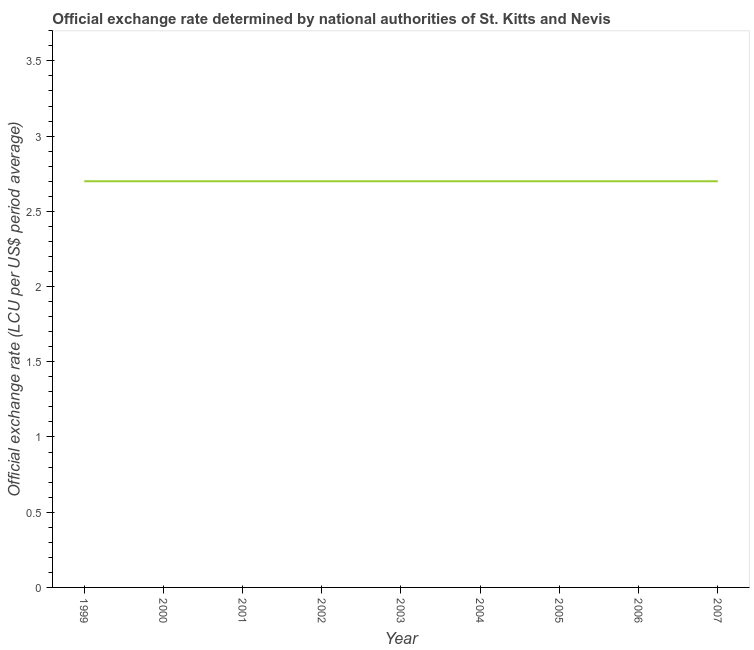What is the official exchange rate in 2004?
Your answer should be compact. 2.7. Across all years, what is the maximum official exchange rate?
Offer a terse response. 2.7. What is the sum of the official exchange rate?
Make the answer very short. 24.3. What is the median official exchange rate?
Give a very brief answer. 2.7. Do a majority of the years between 2002 and 2005 (inclusive) have official exchange rate greater than 0.7 ?
Make the answer very short. Yes. Is the official exchange rate in 1999 less than that in 2007?
Your answer should be compact. No. What is the difference between the highest and the second highest official exchange rate?
Offer a terse response. 0. Is the sum of the official exchange rate in 2001 and 2007 greater than the maximum official exchange rate across all years?
Offer a very short reply. Yes. What is the difference between the highest and the lowest official exchange rate?
Make the answer very short. 0. In how many years, is the official exchange rate greater than the average official exchange rate taken over all years?
Offer a very short reply. 0. How many lines are there?
Your answer should be very brief. 1. How many years are there in the graph?
Keep it short and to the point. 9. Does the graph contain grids?
Make the answer very short. No. What is the title of the graph?
Provide a short and direct response. Official exchange rate determined by national authorities of St. Kitts and Nevis. What is the label or title of the Y-axis?
Ensure brevity in your answer.  Official exchange rate (LCU per US$ period average). What is the Official exchange rate (LCU per US$ period average) in 1999?
Offer a very short reply. 2.7. What is the Official exchange rate (LCU per US$ period average) of 2001?
Make the answer very short. 2.7. What is the Official exchange rate (LCU per US$ period average) of 2005?
Keep it short and to the point. 2.7. What is the Official exchange rate (LCU per US$ period average) in 2006?
Offer a terse response. 2.7. What is the difference between the Official exchange rate (LCU per US$ period average) in 1999 and 2001?
Ensure brevity in your answer.  0. What is the difference between the Official exchange rate (LCU per US$ period average) in 1999 and 2003?
Your answer should be compact. 0. What is the difference between the Official exchange rate (LCU per US$ period average) in 1999 and 2004?
Your answer should be compact. 0. What is the difference between the Official exchange rate (LCU per US$ period average) in 1999 and 2006?
Give a very brief answer. 0. What is the difference between the Official exchange rate (LCU per US$ period average) in 2000 and 2003?
Give a very brief answer. 0. What is the difference between the Official exchange rate (LCU per US$ period average) in 2000 and 2004?
Give a very brief answer. 0. What is the difference between the Official exchange rate (LCU per US$ period average) in 2000 and 2006?
Offer a very short reply. 0. What is the difference between the Official exchange rate (LCU per US$ period average) in 2000 and 2007?
Provide a short and direct response. 0. What is the difference between the Official exchange rate (LCU per US$ period average) in 2001 and 2003?
Provide a succinct answer. 0. What is the difference between the Official exchange rate (LCU per US$ period average) in 2001 and 2004?
Provide a succinct answer. 0. What is the difference between the Official exchange rate (LCU per US$ period average) in 2001 and 2006?
Provide a short and direct response. 0. What is the difference between the Official exchange rate (LCU per US$ period average) in 2002 and 2005?
Your response must be concise. 0. What is the difference between the Official exchange rate (LCU per US$ period average) in 2003 and 2004?
Your answer should be compact. 0. What is the difference between the Official exchange rate (LCU per US$ period average) in 2003 and 2005?
Provide a succinct answer. 0. What is the difference between the Official exchange rate (LCU per US$ period average) in 2003 and 2006?
Keep it short and to the point. 0. What is the difference between the Official exchange rate (LCU per US$ period average) in 2003 and 2007?
Give a very brief answer. 0. What is the difference between the Official exchange rate (LCU per US$ period average) in 2004 and 2005?
Offer a terse response. 0. What is the difference between the Official exchange rate (LCU per US$ period average) in 2004 and 2007?
Make the answer very short. 0. What is the difference between the Official exchange rate (LCU per US$ period average) in 2005 and 2006?
Provide a short and direct response. 0. What is the difference between the Official exchange rate (LCU per US$ period average) in 2005 and 2007?
Provide a short and direct response. 0. What is the ratio of the Official exchange rate (LCU per US$ period average) in 1999 to that in 2000?
Offer a very short reply. 1. What is the ratio of the Official exchange rate (LCU per US$ period average) in 1999 to that in 2005?
Offer a very short reply. 1. What is the ratio of the Official exchange rate (LCU per US$ period average) in 2000 to that in 2001?
Ensure brevity in your answer.  1. What is the ratio of the Official exchange rate (LCU per US$ period average) in 2000 to that in 2002?
Ensure brevity in your answer.  1. What is the ratio of the Official exchange rate (LCU per US$ period average) in 2000 to that in 2004?
Offer a very short reply. 1. What is the ratio of the Official exchange rate (LCU per US$ period average) in 2000 to that in 2005?
Provide a succinct answer. 1. What is the ratio of the Official exchange rate (LCU per US$ period average) in 2001 to that in 2002?
Offer a very short reply. 1. What is the ratio of the Official exchange rate (LCU per US$ period average) in 2001 to that in 2006?
Your answer should be compact. 1. What is the ratio of the Official exchange rate (LCU per US$ period average) in 2001 to that in 2007?
Make the answer very short. 1. What is the ratio of the Official exchange rate (LCU per US$ period average) in 2002 to that in 2004?
Offer a terse response. 1. What is the ratio of the Official exchange rate (LCU per US$ period average) in 2002 to that in 2005?
Provide a short and direct response. 1. What is the ratio of the Official exchange rate (LCU per US$ period average) in 2002 to that in 2007?
Give a very brief answer. 1. What is the ratio of the Official exchange rate (LCU per US$ period average) in 2003 to that in 2004?
Your answer should be compact. 1. What is the ratio of the Official exchange rate (LCU per US$ period average) in 2004 to that in 2005?
Your answer should be compact. 1. What is the ratio of the Official exchange rate (LCU per US$ period average) in 2005 to that in 2007?
Keep it short and to the point. 1. What is the ratio of the Official exchange rate (LCU per US$ period average) in 2006 to that in 2007?
Give a very brief answer. 1. 